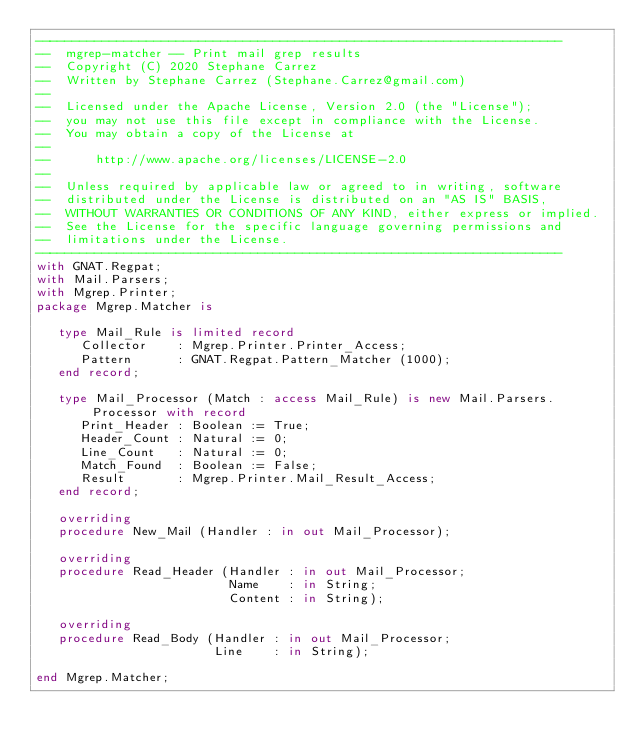<code> <loc_0><loc_0><loc_500><loc_500><_Ada_>-----------------------------------------------------------------------
--  mgrep-matcher -- Print mail grep results
--  Copyright (C) 2020 Stephane Carrez
--  Written by Stephane Carrez (Stephane.Carrez@gmail.com)
--
--  Licensed under the Apache License, Version 2.0 (the "License");
--  you may not use this file except in compliance with the License.
--  You may obtain a copy of the License at
--
--      http://www.apache.org/licenses/LICENSE-2.0
--
--  Unless required by applicable law or agreed to in writing, software
--  distributed under the License is distributed on an "AS IS" BASIS,
--  WITHOUT WARRANTIES OR CONDITIONS OF ANY KIND, either express or implied.
--  See the License for the specific language governing permissions and
--  limitations under the License.
-----------------------------------------------------------------------
with GNAT.Regpat;
with Mail.Parsers;
with Mgrep.Printer;
package Mgrep.Matcher is

   type Mail_Rule is limited record
      Collector    : Mgrep.Printer.Printer_Access;
      Pattern      : GNAT.Regpat.Pattern_Matcher (1000);
   end record;

   type Mail_Processor (Match : access Mail_Rule) is new Mail.Parsers.Processor with record
      Print_Header : Boolean := True;
      Header_Count : Natural := 0;
      Line_Count   : Natural := 0;
      Match_Found  : Boolean := False;
      Result       : Mgrep.Printer.Mail_Result_Access;
   end record;

   overriding
   procedure New_Mail (Handler : in out Mail_Processor);

   overriding
   procedure Read_Header (Handler : in out Mail_Processor;
                          Name    : in String;
                          Content : in String);

   overriding
   procedure Read_Body (Handler : in out Mail_Processor;
                        Line    : in String);

end Mgrep.Matcher;
</code> 